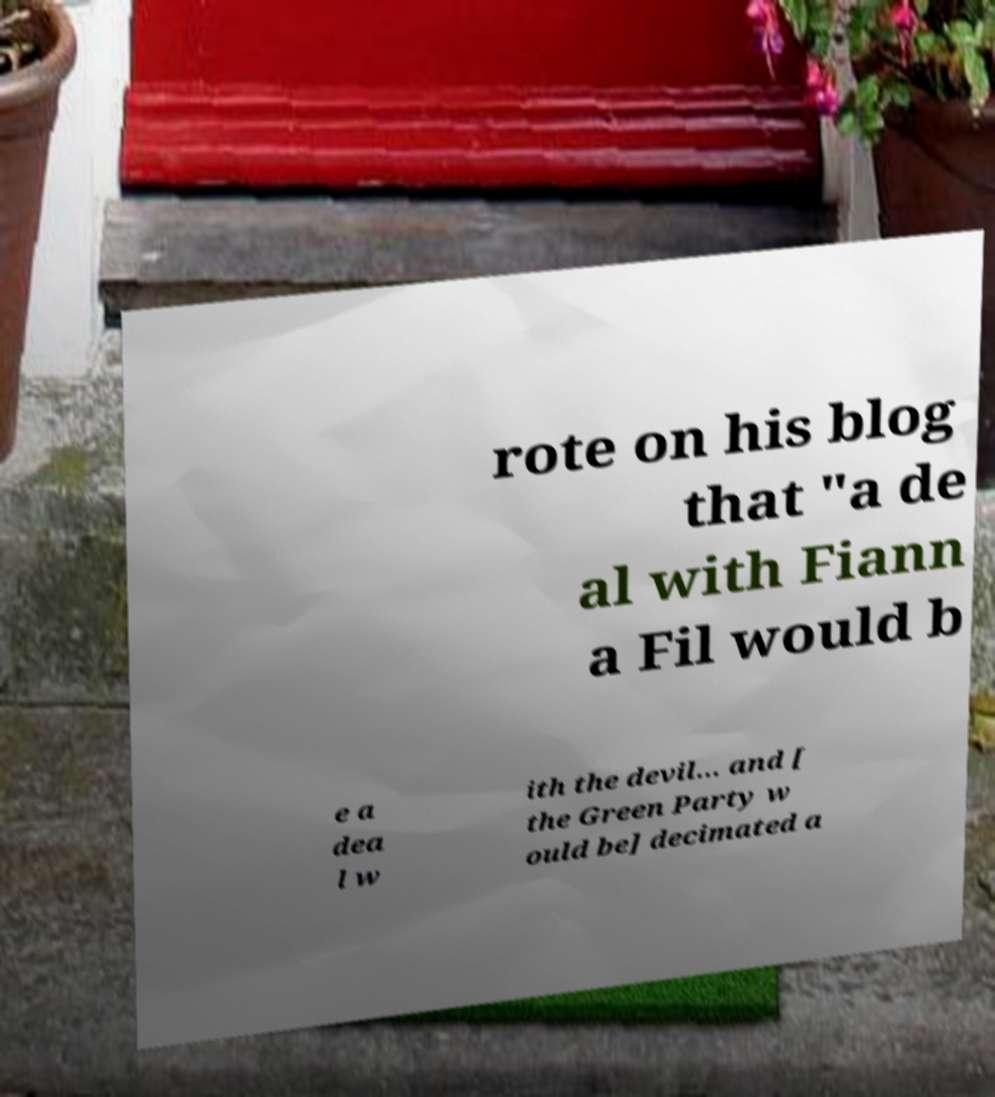Could you extract and type out the text from this image? rote on his blog that "a de al with Fiann a Fil would b e a dea l w ith the devil… and [ the Green Party w ould be] decimated a 